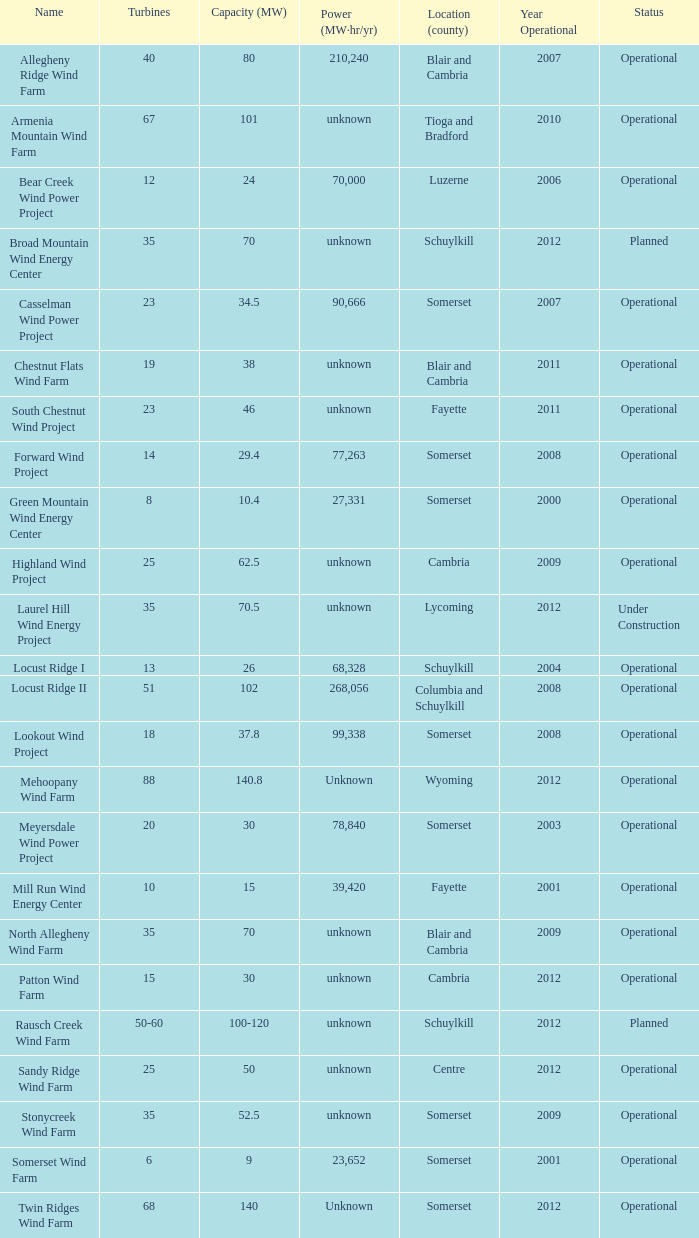Which turbines possess a capacity of 30 and are situated in somerset? 20.0. 